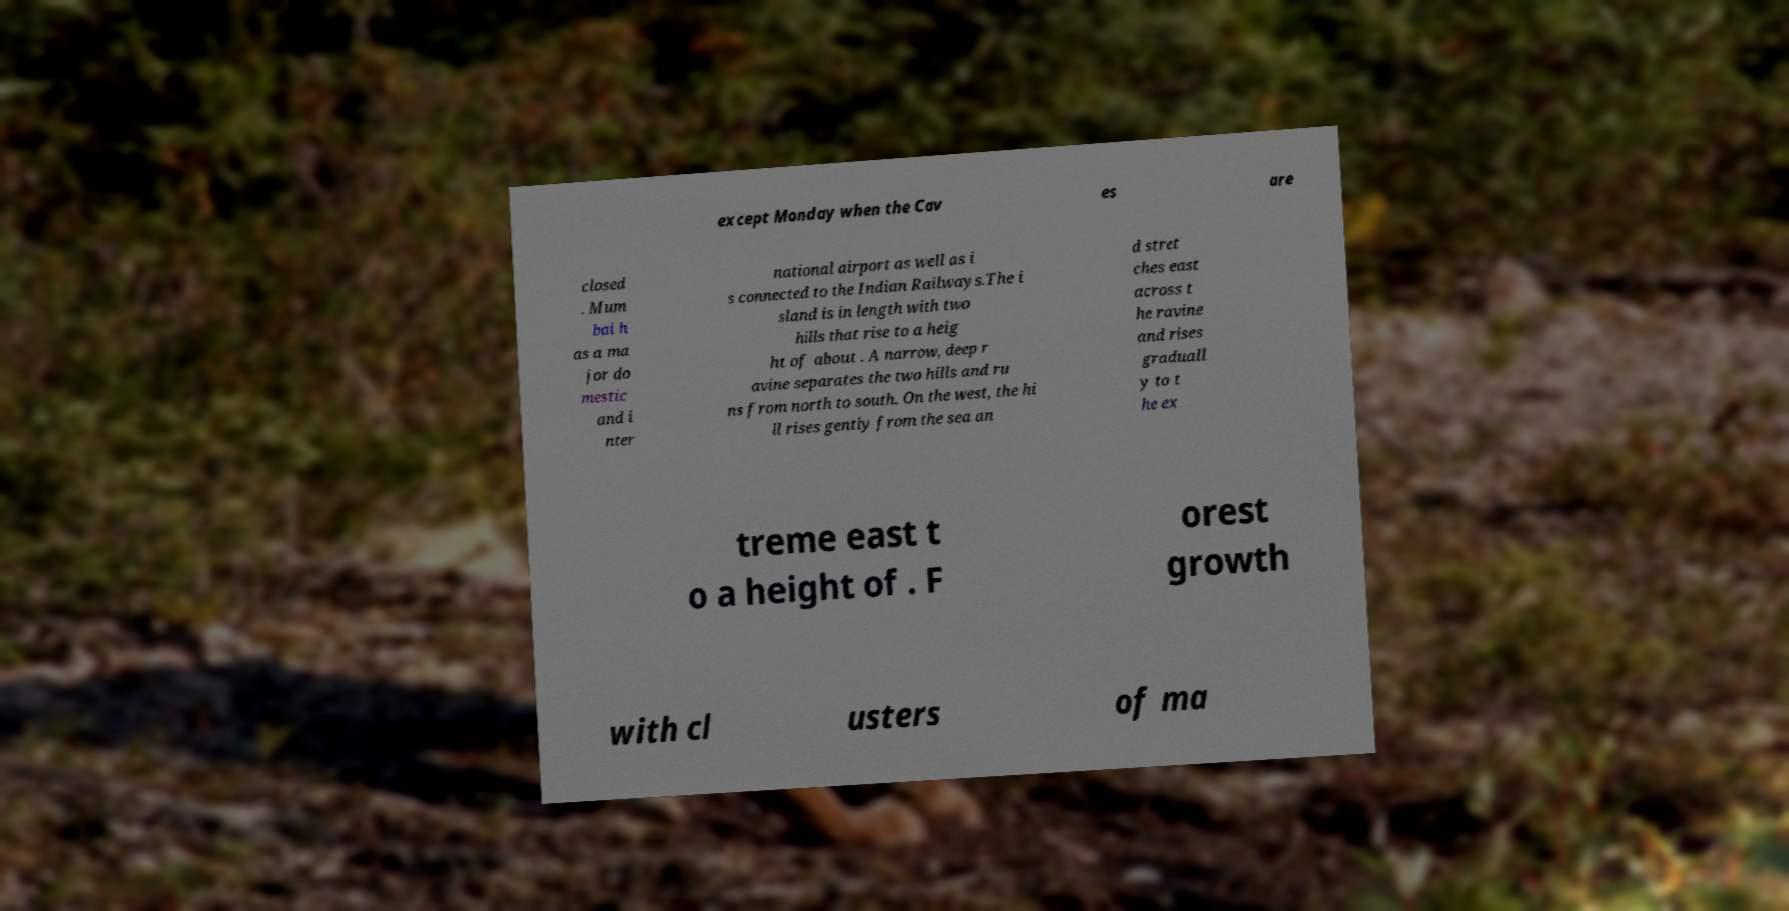Could you extract and type out the text from this image? except Monday when the Cav es are closed . Mum bai h as a ma jor do mestic and i nter national airport as well as i s connected to the Indian Railways.The i sland is in length with two hills that rise to a heig ht of about . A narrow, deep r avine separates the two hills and ru ns from north to south. On the west, the hi ll rises gently from the sea an d stret ches east across t he ravine and rises graduall y to t he ex treme east t o a height of . F orest growth with cl usters of ma 